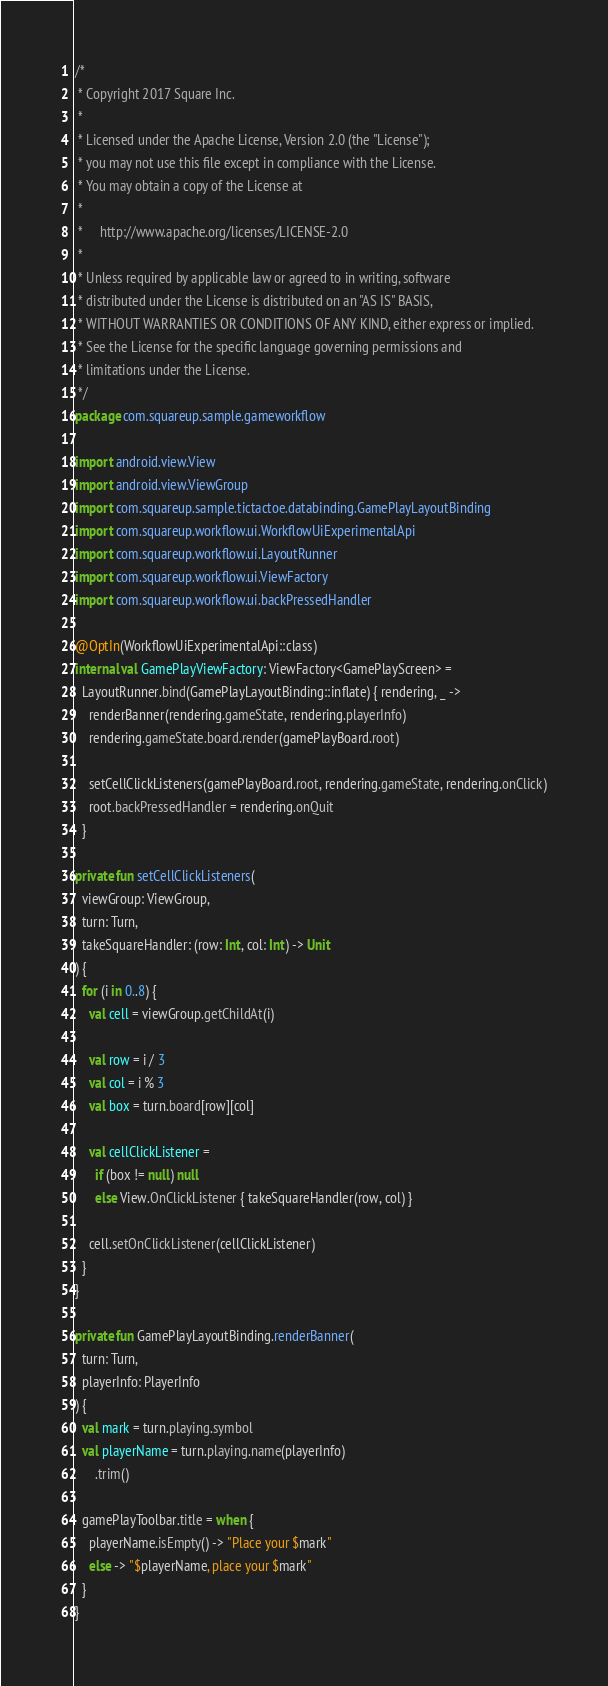<code> <loc_0><loc_0><loc_500><loc_500><_Kotlin_>/*
 * Copyright 2017 Square Inc.
 *
 * Licensed under the Apache License, Version 2.0 (the "License");
 * you may not use this file except in compliance with the License.
 * You may obtain a copy of the License at
 *
 *     http://www.apache.org/licenses/LICENSE-2.0
 *
 * Unless required by applicable law or agreed to in writing, software
 * distributed under the License is distributed on an "AS IS" BASIS,
 * WITHOUT WARRANTIES OR CONDITIONS OF ANY KIND, either express or implied.
 * See the License for the specific language governing permissions and
 * limitations under the License.
 */
package com.squareup.sample.gameworkflow

import android.view.View
import android.view.ViewGroup
import com.squareup.sample.tictactoe.databinding.GamePlayLayoutBinding
import com.squareup.workflow.ui.WorkflowUiExperimentalApi
import com.squareup.workflow.ui.LayoutRunner
import com.squareup.workflow.ui.ViewFactory
import com.squareup.workflow.ui.backPressedHandler

@OptIn(WorkflowUiExperimentalApi::class)
internal val GamePlayViewFactory: ViewFactory<GamePlayScreen> =
  LayoutRunner.bind(GamePlayLayoutBinding::inflate) { rendering, _ ->
    renderBanner(rendering.gameState, rendering.playerInfo)
    rendering.gameState.board.render(gamePlayBoard.root)

    setCellClickListeners(gamePlayBoard.root, rendering.gameState, rendering.onClick)
    root.backPressedHandler = rendering.onQuit
  }

private fun setCellClickListeners(
  viewGroup: ViewGroup,
  turn: Turn,
  takeSquareHandler: (row: Int, col: Int) -> Unit
) {
  for (i in 0..8) {
    val cell = viewGroup.getChildAt(i)

    val row = i / 3
    val col = i % 3
    val box = turn.board[row][col]

    val cellClickListener =
      if (box != null) null
      else View.OnClickListener { takeSquareHandler(row, col) }

    cell.setOnClickListener(cellClickListener)
  }
}

private fun GamePlayLayoutBinding.renderBanner(
  turn: Turn,
  playerInfo: PlayerInfo
) {
  val mark = turn.playing.symbol
  val playerName = turn.playing.name(playerInfo)
      .trim()

  gamePlayToolbar.title = when {
    playerName.isEmpty() -> "Place your $mark"
    else -> "$playerName, place your $mark"
  }
}
</code> 